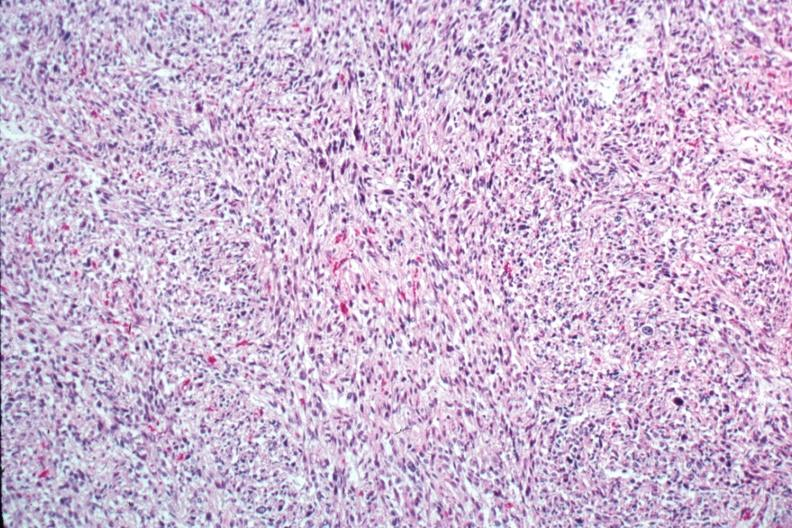where is this from?
Answer the question using a single word or phrase. Female reproductive system 